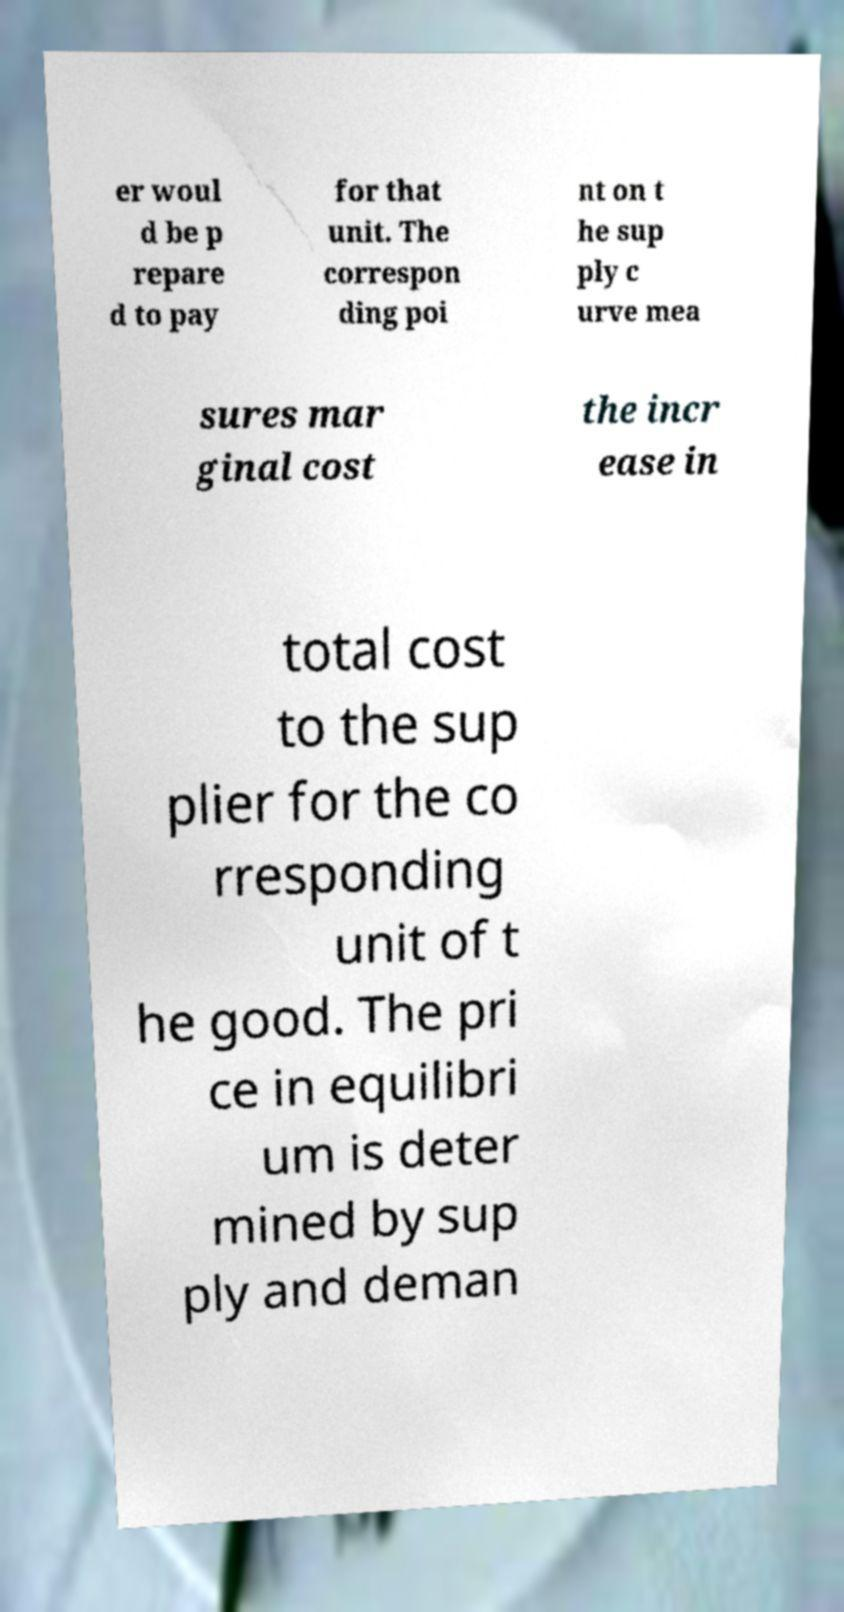Could you extract and type out the text from this image? er woul d be p repare d to pay for that unit. The correspon ding poi nt on t he sup ply c urve mea sures mar ginal cost the incr ease in total cost to the sup plier for the co rresponding unit of t he good. The pri ce in equilibri um is deter mined by sup ply and deman 